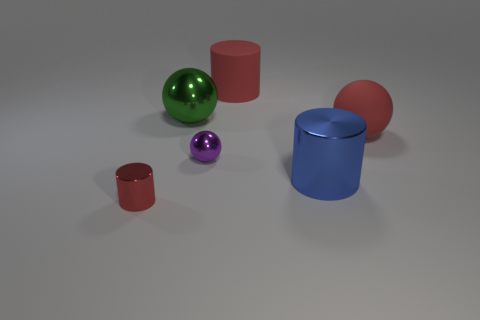Subtract all green cylinders. Subtract all cyan balls. How many cylinders are left? 3 Add 4 large shiny balls. How many objects exist? 10 Add 3 red cylinders. How many red cylinders are left? 5 Add 1 green objects. How many green objects exist? 2 Subtract 1 purple spheres. How many objects are left? 5 Subtract all small green cylinders. Subtract all purple balls. How many objects are left? 5 